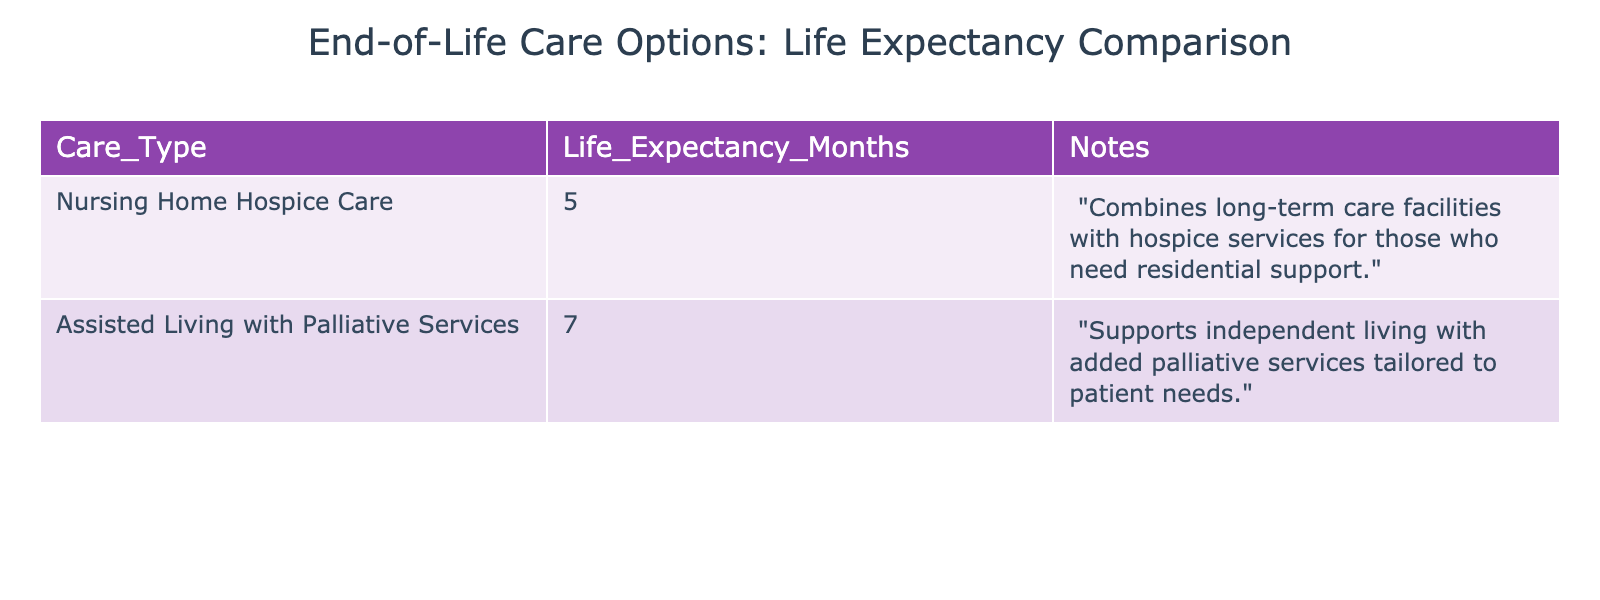What is the life expectancy in months for Nursing Home Hospice Care? The table indicates that the life expectancy for Nursing Home Hospice Care is listed under the "Life Expectancy Months" column, which shows the value of 5 months.
Answer: 5 What type of care offers a longer life expectancy, Assisted Living with Palliative Services or Nursing Home Hospice Care? By comparing the life expectancy values in the table, Assisted Living with Palliative Services is shown to have a life expectancy of 7 months while Nursing Home Hospice Care has a life expectancy of 5 months. Therefore, Assisted Living offers a longer life expectancy.
Answer: Assisted Living with Palliative Services What is the difference in life expectancy between the two care types? The life expectancy for Assisted Living with Palliative Services is 7 months, and for Nursing Home Hospice Care, it is 5 months. The difference is calculated as 7 - 5 = 2 months.
Answer: 2 months Is it true that Nursing Home Hospice Care provides a longer life expectancy than Assisted Living with Palliative Services? To determine this, we compare the life expectancy values: Nursing Home Hospice Care has a life expectancy of 5 months, while Assisted Living with Palliative Services has 7 months. Since 5 is less than 7, the statement is false.
Answer: No If someone chooses Assisted Living with Palliative Services, what is the minimum expected life expectancy in months based on the table? The life expectancy provided for Assisted Living with Palliative Services in the table is 7 months, which is directly listed as the value for that care type. Therefore, the minimum expected life expectancy is 7 months.
Answer: 7 months 